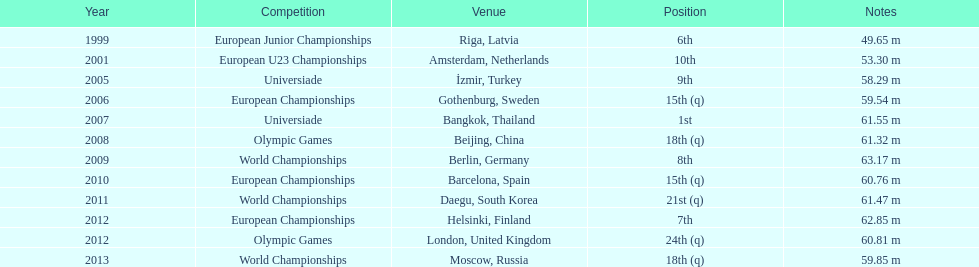Which year experienced the greatest number of contests? 2012. 